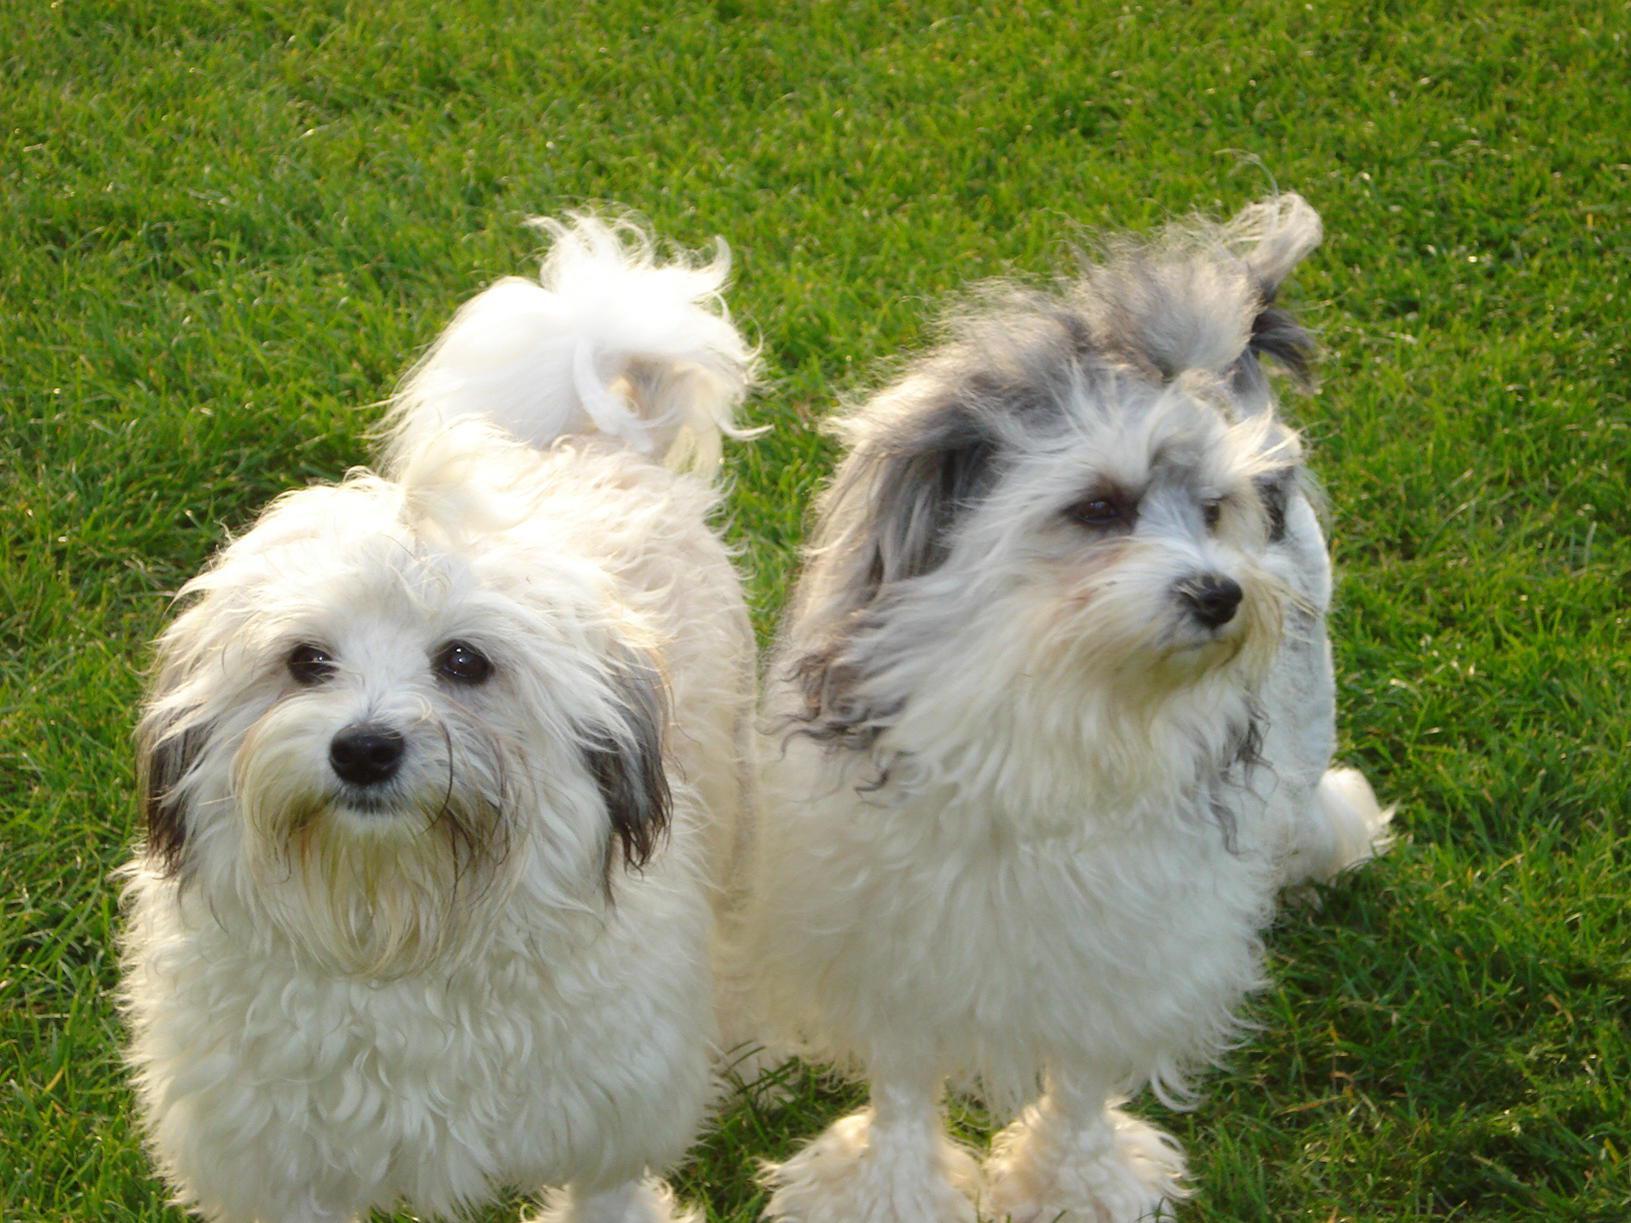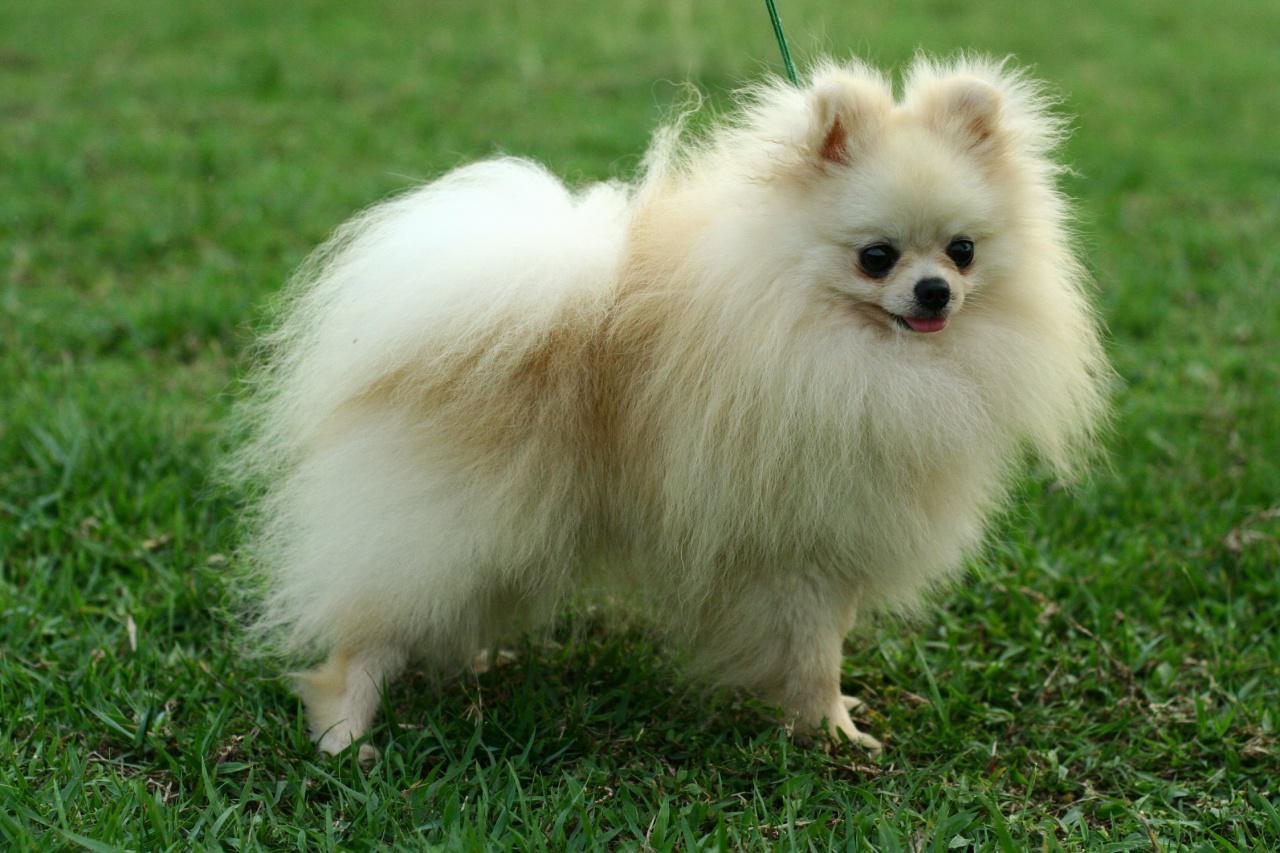The first image is the image on the left, the second image is the image on the right. Examine the images to the left and right. Is the description "There is one black dog" accurate? Answer yes or no. No. 